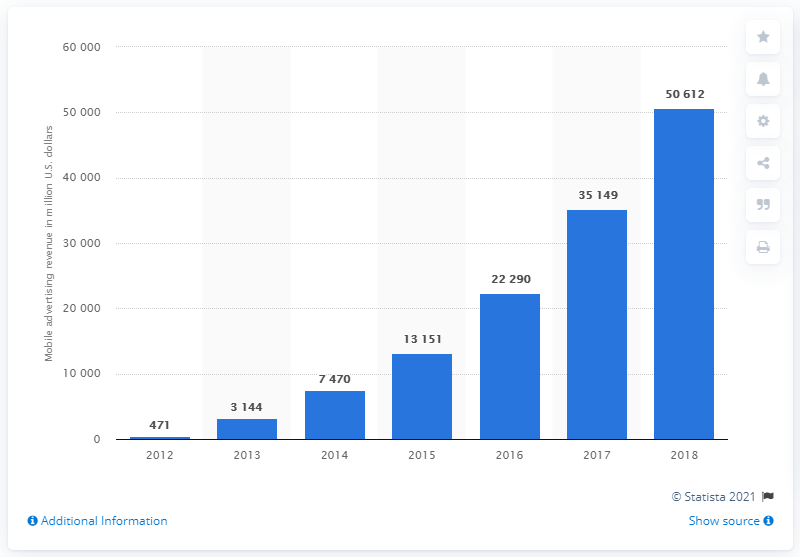Give some essential details in this illustration. In the most recent fiscal year, Facebook generated approximately $506,120 in mobile ad revenues. 